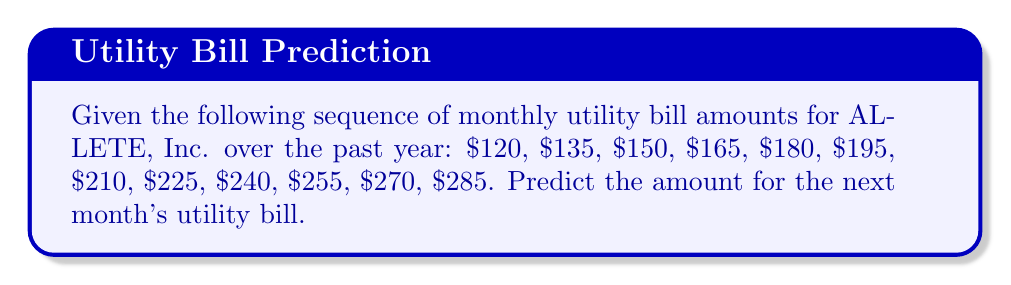Could you help me with this problem? To predict the next value in this sequence, we need to identify the pattern:

1. Calculate the difference between consecutive terms:
   $135 - 120 = 15$
   $150 - 135 = 15$
   $165 - 150 = 15$
   ...and so on.

2. We observe that the difference between each consecutive term is constant: $15.

3. This indicates an arithmetic sequence with a common difference of 15.

4. The general formula for an arithmetic sequence is:
   $a_n = a_1 + (n-1)d$
   Where $a_n$ is the nth term, $a_1$ is the first term, $n$ is the position, and $d$ is the common difference.

5. In this case, $a_1 = 120$, $d = 15$, and we're looking for the 13th term (next month).

6. Plugging into the formula:
   $a_{13} = 120 + (13-1)15$
   $a_{13} = 120 + (12)15$
   $a_{13} = 120 + 180$
   $a_{13} = 300$

Therefore, the predicted utility bill amount for the next month is $300.
Answer: $300 